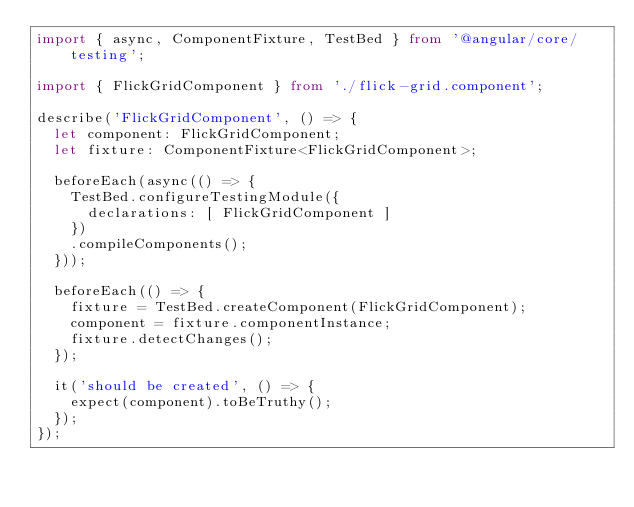Convert code to text. <code><loc_0><loc_0><loc_500><loc_500><_TypeScript_>import { async, ComponentFixture, TestBed } from '@angular/core/testing';

import { FlickGridComponent } from './flick-grid.component';

describe('FlickGridComponent', () => {
  let component: FlickGridComponent;
  let fixture: ComponentFixture<FlickGridComponent>;

  beforeEach(async(() => {
    TestBed.configureTestingModule({
      declarations: [ FlickGridComponent ]
    })
    .compileComponents();
  }));

  beforeEach(() => {
    fixture = TestBed.createComponent(FlickGridComponent);
    component = fixture.componentInstance;
    fixture.detectChanges();
  });

  it('should be created', () => {
    expect(component).toBeTruthy();
  });
});
</code> 